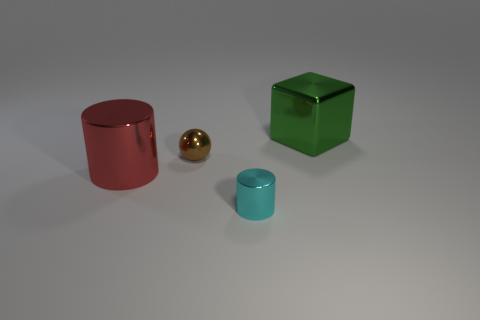Does the small cyan object have the same shape as the large thing that is on the left side of the cyan thing?
Give a very brief answer. Yes. The cyan object is what size?
Give a very brief answer. Small. Are there fewer brown metal objects that are left of the brown thing than big green objects?
Make the answer very short. Yes. What number of things have the same size as the red metal cylinder?
Keep it short and to the point. 1. There is a ball; what number of cubes are on the right side of it?
Your answer should be very brief. 1. Are there any other objects that have the same shape as the cyan object?
Ensure brevity in your answer.  Yes. What color is the other thing that is the same size as the red metal object?
Keep it short and to the point. Green. Is the number of big green metal cubes behind the cyan cylinder less than the number of green objects that are to the right of the large cube?
Provide a short and direct response. No. Do the shiny cylinder that is to the left of the cyan cylinder and the tiny cyan metallic cylinder have the same size?
Your answer should be very brief. No. There is a small metal object that is in front of the big metallic cylinder; what shape is it?
Provide a short and direct response. Cylinder. 